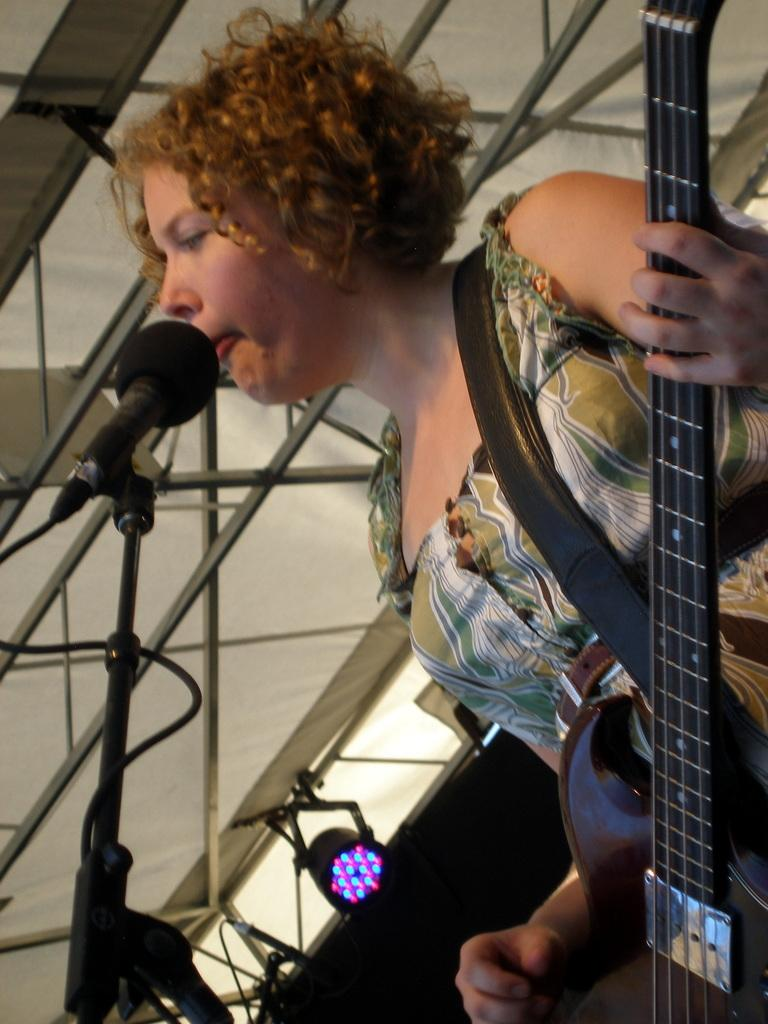Who is the main subject in the image? There is a woman in the image. What is the woman holding in the image? The woman is holding a guitar. What is in front of the woman in the image? There is a microphone in front of the woman. What can be seen in the background of the image? There is light, rods, and other objects in the background of the image. What type of wax is being used to create the guitar in the image? There is no wax being used to create the guitar in the image; it is a complete instrument. What type of steel is being used to create the rods in the background of the image? There is no information about the type of steel used for the rods in the background of the image. 